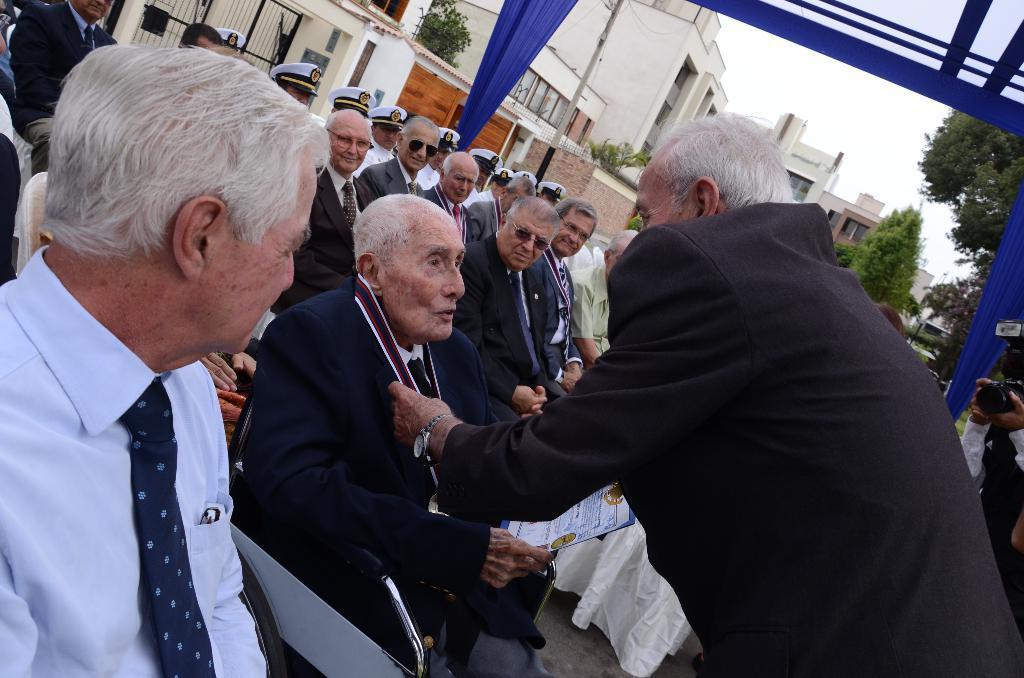Can you describe this image briefly? In this image there are group of people sitting, and one person is standing and he is doing something. And in the background there are some buildings, curtains, trees, poles on the right side there is one person who is holding the camera and clicking pictures. At the bottom of the image there is a cloth. 